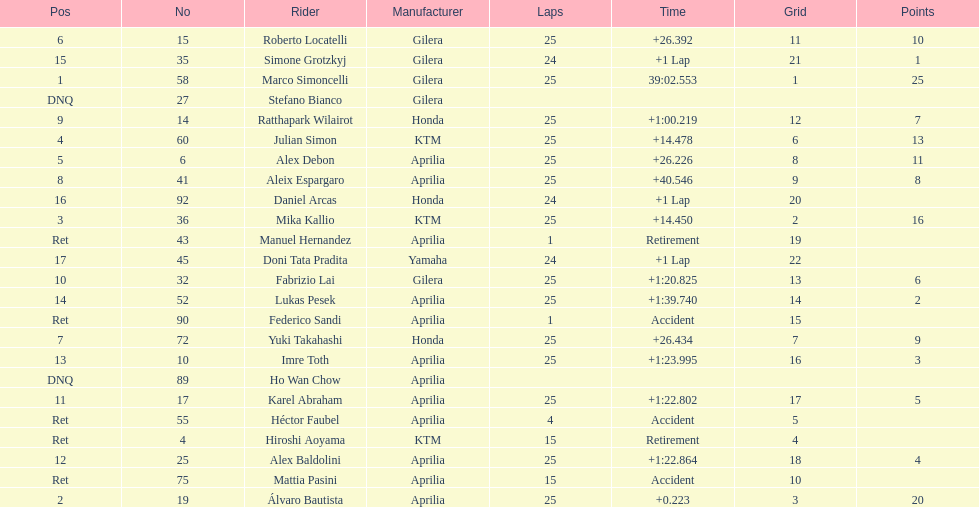The total amount of riders who did not qualify 2. 